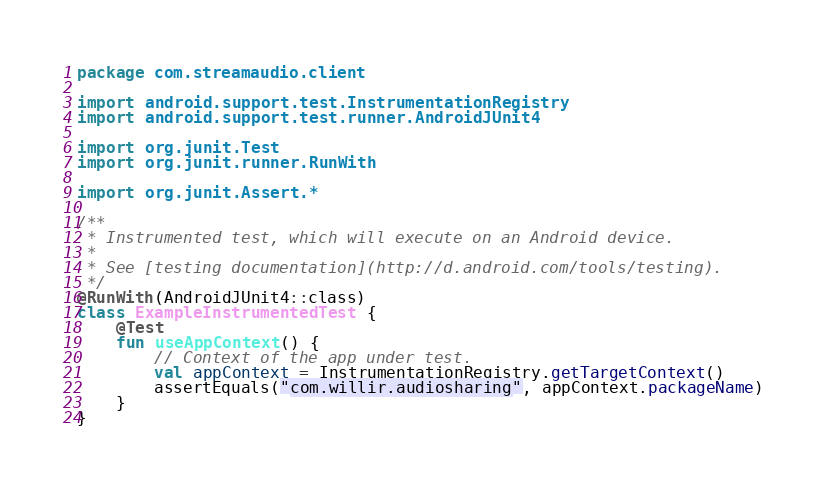Convert code to text. <code><loc_0><loc_0><loc_500><loc_500><_Kotlin_>package com.streamaudio.client

import android.support.test.InstrumentationRegistry
import android.support.test.runner.AndroidJUnit4

import org.junit.Test
import org.junit.runner.RunWith

import org.junit.Assert.*

/**
 * Instrumented test, which will execute on an Android device.
 *
 * See [testing documentation](http://d.android.com/tools/testing).
 */
@RunWith(AndroidJUnit4::class)
class ExampleInstrumentedTest {
    @Test
    fun useAppContext() {
        // Context of the app under test.
        val appContext = InstrumentationRegistry.getTargetContext()
        assertEquals("com.willir.audiosharing", appContext.packageName)
    }
}
</code> 